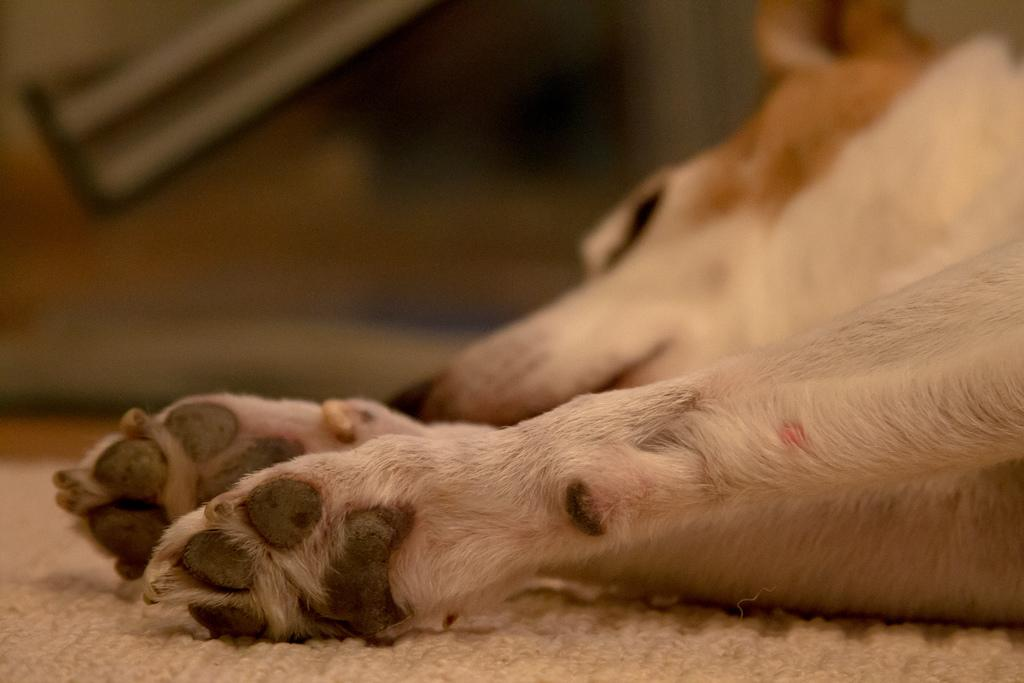What type of animal is present in the image? There is a dog in the image. Where is the dog located? The dog is on a mat. Can you describe the background of the image? The background of the image is blurred. What reward is the dog holding in its pocket in the image? There is no reward visible in the image, and dogs do not have pockets. 